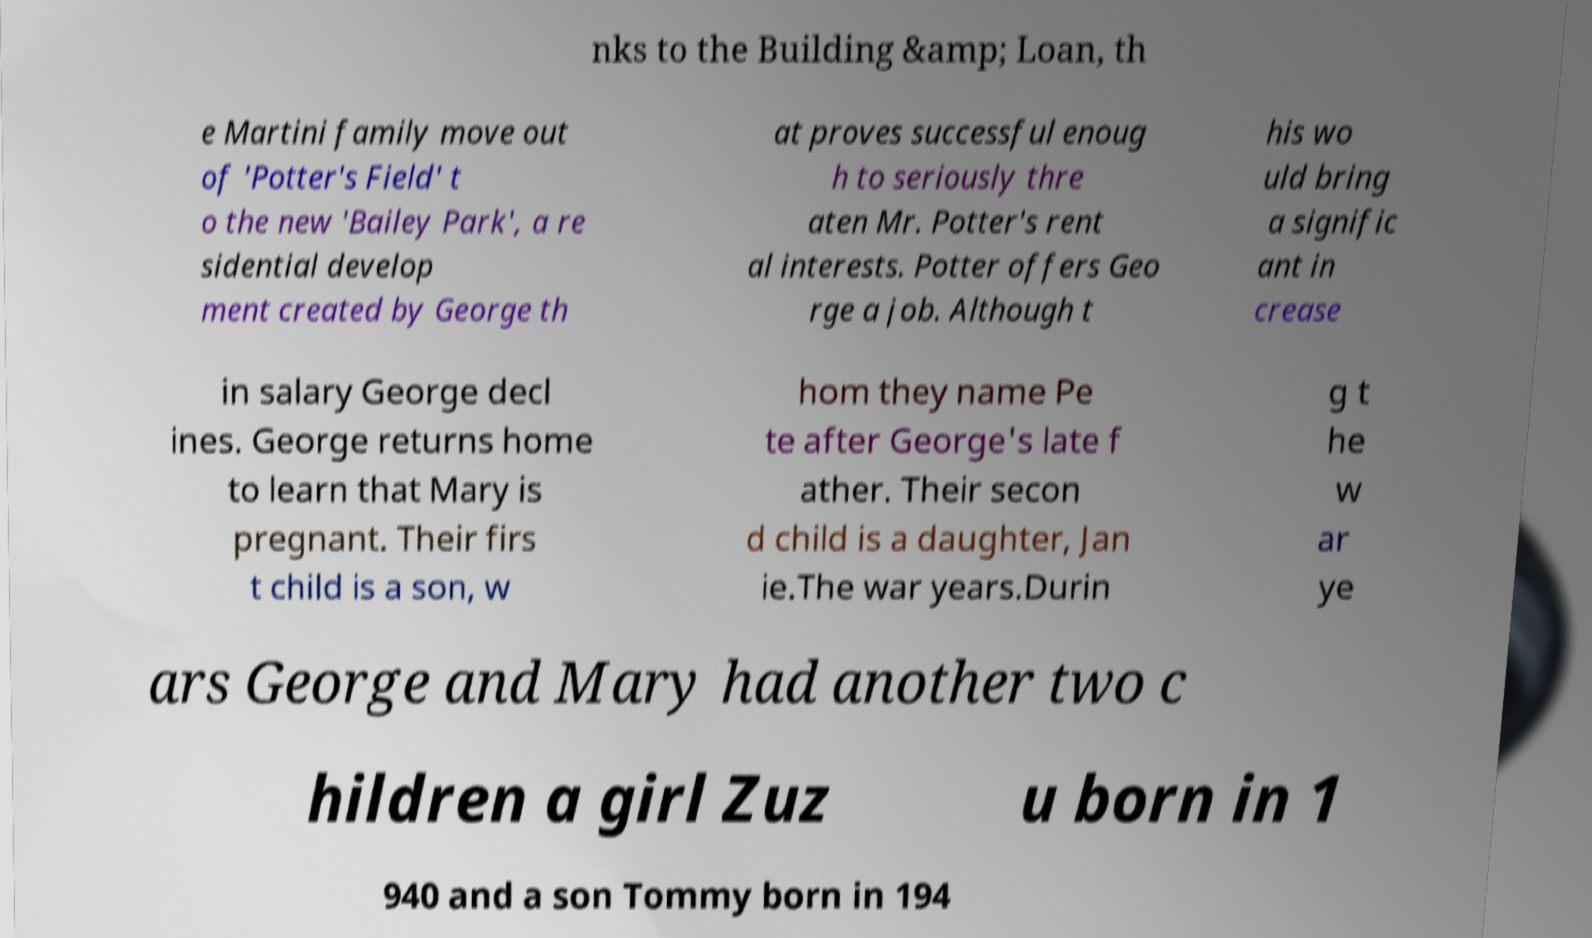What messages or text are displayed in this image? I need them in a readable, typed format. nks to the Building &amp; Loan, th e Martini family move out of 'Potter's Field' t o the new 'Bailey Park', a re sidential develop ment created by George th at proves successful enoug h to seriously thre aten Mr. Potter's rent al interests. Potter offers Geo rge a job. Although t his wo uld bring a signific ant in crease in salary George decl ines. George returns home to learn that Mary is pregnant. Their firs t child is a son, w hom they name Pe te after George's late f ather. Their secon d child is a daughter, Jan ie.The war years.Durin g t he w ar ye ars George and Mary had another two c hildren a girl Zuz u born in 1 940 and a son Tommy born in 194 